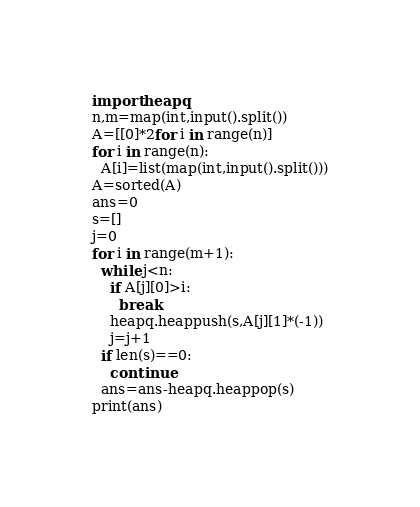<code> <loc_0><loc_0><loc_500><loc_500><_Python_>import heapq
n,m=map(int,input().split())
A=[[0]*2for i in range(n)]
for i in range(n):
  A[i]=list(map(int,input().split()))
A=sorted(A)
ans=0
s=[]
j=0
for i in range(m+1):
  while j<n:
    if A[j][0]>i:
      break
    heapq.heappush(s,A[j][1]*(-1))
    j=j+1
  if len(s)==0:
    continue
  ans=ans-heapq.heappop(s)
print(ans)</code> 